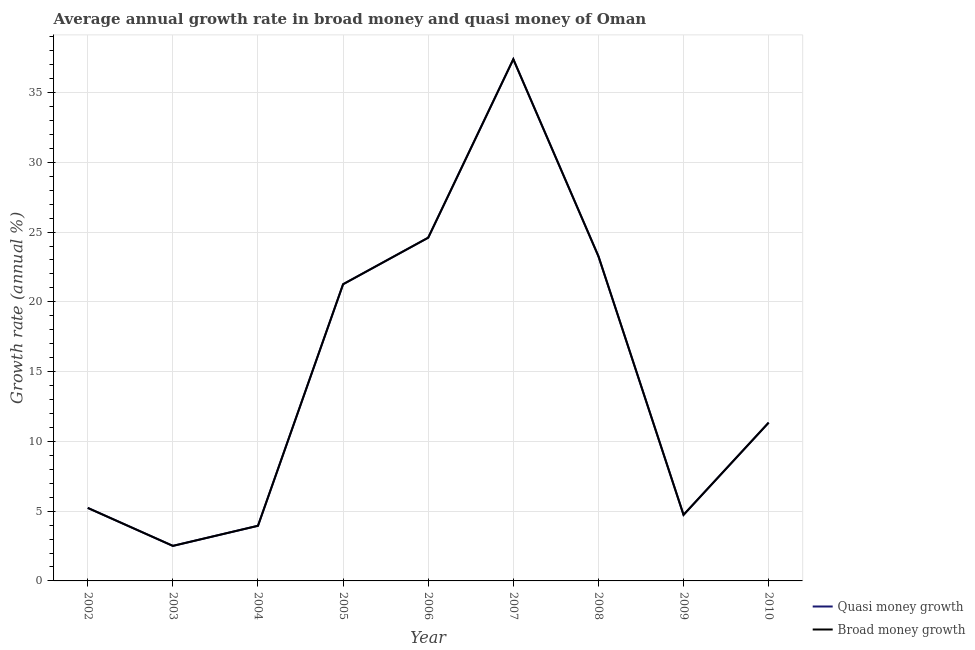Does the line corresponding to annual growth rate in broad money intersect with the line corresponding to annual growth rate in quasi money?
Offer a terse response. Yes. Is the number of lines equal to the number of legend labels?
Provide a succinct answer. Yes. What is the annual growth rate in quasi money in 2002?
Offer a very short reply. 5.23. Across all years, what is the maximum annual growth rate in quasi money?
Provide a succinct answer. 37.39. Across all years, what is the minimum annual growth rate in quasi money?
Provide a short and direct response. 2.51. In which year was the annual growth rate in quasi money minimum?
Offer a very short reply. 2003. What is the total annual growth rate in quasi money in the graph?
Keep it short and to the point. 134.28. What is the difference between the annual growth rate in broad money in 2005 and that in 2006?
Your response must be concise. -3.34. What is the difference between the annual growth rate in broad money in 2006 and the annual growth rate in quasi money in 2005?
Provide a succinct answer. 3.34. What is the average annual growth rate in broad money per year?
Offer a very short reply. 14.92. What is the ratio of the annual growth rate in quasi money in 2002 to that in 2008?
Give a very brief answer. 0.22. Is the annual growth rate in quasi money in 2002 less than that in 2003?
Give a very brief answer. No. What is the difference between the highest and the second highest annual growth rate in quasi money?
Provide a short and direct response. 12.79. What is the difference between the highest and the lowest annual growth rate in broad money?
Ensure brevity in your answer.  34.87. In how many years, is the annual growth rate in broad money greater than the average annual growth rate in broad money taken over all years?
Your answer should be very brief. 4. How many lines are there?
Keep it short and to the point. 2. Are the values on the major ticks of Y-axis written in scientific E-notation?
Your answer should be compact. No. Does the graph contain any zero values?
Ensure brevity in your answer.  No. Does the graph contain grids?
Keep it short and to the point. Yes. Where does the legend appear in the graph?
Ensure brevity in your answer.  Bottom right. What is the title of the graph?
Offer a terse response. Average annual growth rate in broad money and quasi money of Oman. Does "State government" appear as one of the legend labels in the graph?
Your answer should be very brief. No. What is the label or title of the X-axis?
Keep it short and to the point. Year. What is the label or title of the Y-axis?
Your answer should be very brief. Growth rate (annual %). What is the Growth rate (annual %) in Quasi money growth in 2002?
Your answer should be compact. 5.23. What is the Growth rate (annual %) in Broad money growth in 2002?
Offer a very short reply. 5.23. What is the Growth rate (annual %) in Quasi money growth in 2003?
Make the answer very short. 2.51. What is the Growth rate (annual %) of Broad money growth in 2003?
Your answer should be very brief. 2.51. What is the Growth rate (annual %) in Quasi money growth in 2004?
Offer a terse response. 3.95. What is the Growth rate (annual %) of Broad money growth in 2004?
Provide a short and direct response. 3.95. What is the Growth rate (annual %) of Quasi money growth in 2005?
Provide a succinct answer. 21.26. What is the Growth rate (annual %) of Broad money growth in 2005?
Keep it short and to the point. 21.26. What is the Growth rate (annual %) in Quasi money growth in 2006?
Give a very brief answer. 24.6. What is the Growth rate (annual %) in Broad money growth in 2006?
Offer a terse response. 24.6. What is the Growth rate (annual %) of Quasi money growth in 2007?
Your answer should be compact. 37.39. What is the Growth rate (annual %) of Broad money growth in 2007?
Offer a very short reply. 37.39. What is the Growth rate (annual %) of Quasi money growth in 2008?
Give a very brief answer. 23.27. What is the Growth rate (annual %) of Broad money growth in 2008?
Give a very brief answer. 23.27. What is the Growth rate (annual %) in Quasi money growth in 2009?
Your response must be concise. 4.73. What is the Growth rate (annual %) of Broad money growth in 2009?
Provide a succinct answer. 4.73. What is the Growth rate (annual %) in Quasi money growth in 2010?
Keep it short and to the point. 11.34. What is the Growth rate (annual %) of Broad money growth in 2010?
Give a very brief answer. 11.34. Across all years, what is the maximum Growth rate (annual %) of Quasi money growth?
Your answer should be very brief. 37.39. Across all years, what is the maximum Growth rate (annual %) of Broad money growth?
Offer a terse response. 37.39. Across all years, what is the minimum Growth rate (annual %) in Quasi money growth?
Your response must be concise. 2.51. Across all years, what is the minimum Growth rate (annual %) in Broad money growth?
Offer a very short reply. 2.51. What is the total Growth rate (annual %) of Quasi money growth in the graph?
Provide a short and direct response. 134.28. What is the total Growth rate (annual %) of Broad money growth in the graph?
Ensure brevity in your answer.  134.28. What is the difference between the Growth rate (annual %) in Quasi money growth in 2002 and that in 2003?
Make the answer very short. 2.72. What is the difference between the Growth rate (annual %) of Broad money growth in 2002 and that in 2003?
Provide a short and direct response. 2.72. What is the difference between the Growth rate (annual %) of Quasi money growth in 2002 and that in 2004?
Ensure brevity in your answer.  1.28. What is the difference between the Growth rate (annual %) in Broad money growth in 2002 and that in 2004?
Your response must be concise. 1.28. What is the difference between the Growth rate (annual %) of Quasi money growth in 2002 and that in 2005?
Offer a very short reply. -16.03. What is the difference between the Growth rate (annual %) of Broad money growth in 2002 and that in 2005?
Make the answer very short. -16.03. What is the difference between the Growth rate (annual %) of Quasi money growth in 2002 and that in 2006?
Provide a short and direct response. -19.36. What is the difference between the Growth rate (annual %) in Broad money growth in 2002 and that in 2006?
Give a very brief answer. -19.36. What is the difference between the Growth rate (annual %) of Quasi money growth in 2002 and that in 2007?
Ensure brevity in your answer.  -32.15. What is the difference between the Growth rate (annual %) in Broad money growth in 2002 and that in 2007?
Make the answer very short. -32.15. What is the difference between the Growth rate (annual %) in Quasi money growth in 2002 and that in 2008?
Keep it short and to the point. -18.03. What is the difference between the Growth rate (annual %) in Broad money growth in 2002 and that in 2008?
Provide a short and direct response. -18.03. What is the difference between the Growth rate (annual %) of Quasi money growth in 2002 and that in 2009?
Keep it short and to the point. 0.5. What is the difference between the Growth rate (annual %) of Broad money growth in 2002 and that in 2009?
Your answer should be compact. 0.5. What is the difference between the Growth rate (annual %) of Quasi money growth in 2002 and that in 2010?
Offer a very short reply. -6.11. What is the difference between the Growth rate (annual %) in Broad money growth in 2002 and that in 2010?
Your answer should be compact. -6.11. What is the difference between the Growth rate (annual %) in Quasi money growth in 2003 and that in 2004?
Make the answer very short. -1.44. What is the difference between the Growth rate (annual %) in Broad money growth in 2003 and that in 2004?
Ensure brevity in your answer.  -1.44. What is the difference between the Growth rate (annual %) of Quasi money growth in 2003 and that in 2005?
Ensure brevity in your answer.  -18.75. What is the difference between the Growth rate (annual %) in Broad money growth in 2003 and that in 2005?
Provide a short and direct response. -18.75. What is the difference between the Growth rate (annual %) of Quasi money growth in 2003 and that in 2006?
Offer a very short reply. -22.08. What is the difference between the Growth rate (annual %) in Broad money growth in 2003 and that in 2006?
Offer a very short reply. -22.08. What is the difference between the Growth rate (annual %) of Quasi money growth in 2003 and that in 2007?
Your answer should be compact. -34.87. What is the difference between the Growth rate (annual %) of Broad money growth in 2003 and that in 2007?
Ensure brevity in your answer.  -34.87. What is the difference between the Growth rate (annual %) in Quasi money growth in 2003 and that in 2008?
Give a very brief answer. -20.76. What is the difference between the Growth rate (annual %) in Broad money growth in 2003 and that in 2008?
Offer a terse response. -20.76. What is the difference between the Growth rate (annual %) in Quasi money growth in 2003 and that in 2009?
Offer a terse response. -2.22. What is the difference between the Growth rate (annual %) in Broad money growth in 2003 and that in 2009?
Give a very brief answer. -2.22. What is the difference between the Growth rate (annual %) in Quasi money growth in 2003 and that in 2010?
Offer a terse response. -8.83. What is the difference between the Growth rate (annual %) in Broad money growth in 2003 and that in 2010?
Ensure brevity in your answer.  -8.83. What is the difference between the Growth rate (annual %) of Quasi money growth in 2004 and that in 2005?
Give a very brief answer. -17.31. What is the difference between the Growth rate (annual %) of Broad money growth in 2004 and that in 2005?
Give a very brief answer. -17.31. What is the difference between the Growth rate (annual %) in Quasi money growth in 2004 and that in 2006?
Your answer should be compact. -20.64. What is the difference between the Growth rate (annual %) of Broad money growth in 2004 and that in 2006?
Your answer should be compact. -20.64. What is the difference between the Growth rate (annual %) in Quasi money growth in 2004 and that in 2007?
Provide a succinct answer. -33.43. What is the difference between the Growth rate (annual %) in Broad money growth in 2004 and that in 2007?
Offer a terse response. -33.43. What is the difference between the Growth rate (annual %) in Quasi money growth in 2004 and that in 2008?
Give a very brief answer. -19.31. What is the difference between the Growth rate (annual %) of Broad money growth in 2004 and that in 2008?
Your answer should be compact. -19.31. What is the difference between the Growth rate (annual %) in Quasi money growth in 2004 and that in 2009?
Ensure brevity in your answer.  -0.78. What is the difference between the Growth rate (annual %) of Broad money growth in 2004 and that in 2009?
Offer a terse response. -0.78. What is the difference between the Growth rate (annual %) in Quasi money growth in 2004 and that in 2010?
Your response must be concise. -7.39. What is the difference between the Growth rate (annual %) in Broad money growth in 2004 and that in 2010?
Offer a terse response. -7.39. What is the difference between the Growth rate (annual %) of Quasi money growth in 2005 and that in 2006?
Ensure brevity in your answer.  -3.34. What is the difference between the Growth rate (annual %) of Broad money growth in 2005 and that in 2006?
Your response must be concise. -3.34. What is the difference between the Growth rate (annual %) of Quasi money growth in 2005 and that in 2007?
Your response must be concise. -16.13. What is the difference between the Growth rate (annual %) in Broad money growth in 2005 and that in 2007?
Your answer should be very brief. -16.13. What is the difference between the Growth rate (annual %) of Quasi money growth in 2005 and that in 2008?
Give a very brief answer. -2.01. What is the difference between the Growth rate (annual %) of Broad money growth in 2005 and that in 2008?
Ensure brevity in your answer.  -2.01. What is the difference between the Growth rate (annual %) in Quasi money growth in 2005 and that in 2009?
Ensure brevity in your answer.  16.53. What is the difference between the Growth rate (annual %) in Broad money growth in 2005 and that in 2009?
Give a very brief answer. 16.53. What is the difference between the Growth rate (annual %) in Quasi money growth in 2005 and that in 2010?
Your answer should be compact. 9.92. What is the difference between the Growth rate (annual %) in Broad money growth in 2005 and that in 2010?
Give a very brief answer. 9.92. What is the difference between the Growth rate (annual %) in Quasi money growth in 2006 and that in 2007?
Offer a very short reply. -12.79. What is the difference between the Growth rate (annual %) in Broad money growth in 2006 and that in 2007?
Ensure brevity in your answer.  -12.79. What is the difference between the Growth rate (annual %) in Quasi money growth in 2006 and that in 2008?
Your response must be concise. 1.33. What is the difference between the Growth rate (annual %) in Broad money growth in 2006 and that in 2008?
Ensure brevity in your answer.  1.33. What is the difference between the Growth rate (annual %) in Quasi money growth in 2006 and that in 2009?
Offer a very short reply. 19.86. What is the difference between the Growth rate (annual %) of Broad money growth in 2006 and that in 2009?
Give a very brief answer. 19.86. What is the difference between the Growth rate (annual %) in Quasi money growth in 2006 and that in 2010?
Give a very brief answer. 13.25. What is the difference between the Growth rate (annual %) in Broad money growth in 2006 and that in 2010?
Make the answer very short. 13.25. What is the difference between the Growth rate (annual %) of Quasi money growth in 2007 and that in 2008?
Your response must be concise. 14.12. What is the difference between the Growth rate (annual %) in Broad money growth in 2007 and that in 2008?
Your answer should be compact. 14.12. What is the difference between the Growth rate (annual %) in Quasi money growth in 2007 and that in 2009?
Make the answer very short. 32.65. What is the difference between the Growth rate (annual %) in Broad money growth in 2007 and that in 2009?
Your answer should be compact. 32.65. What is the difference between the Growth rate (annual %) of Quasi money growth in 2007 and that in 2010?
Provide a succinct answer. 26.04. What is the difference between the Growth rate (annual %) of Broad money growth in 2007 and that in 2010?
Offer a terse response. 26.04. What is the difference between the Growth rate (annual %) of Quasi money growth in 2008 and that in 2009?
Your answer should be compact. 18.53. What is the difference between the Growth rate (annual %) in Broad money growth in 2008 and that in 2009?
Ensure brevity in your answer.  18.53. What is the difference between the Growth rate (annual %) in Quasi money growth in 2008 and that in 2010?
Offer a very short reply. 11.92. What is the difference between the Growth rate (annual %) in Broad money growth in 2008 and that in 2010?
Give a very brief answer. 11.92. What is the difference between the Growth rate (annual %) in Quasi money growth in 2009 and that in 2010?
Make the answer very short. -6.61. What is the difference between the Growth rate (annual %) of Broad money growth in 2009 and that in 2010?
Your answer should be compact. -6.61. What is the difference between the Growth rate (annual %) of Quasi money growth in 2002 and the Growth rate (annual %) of Broad money growth in 2003?
Make the answer very short. 2.72. What is the difference between the Growth rate (annual %) of Quasi money growth in 2002 and the Growth rate (annual %) of Broad money growth in 2004?
Make the answer very short. 1.28. What is the difference between the Growth rate (annual %) in Quasi money growth in 2002 and the Growth rate (annual %) in Broad money growth in 2005?
Keep it short and to the point. -16.03. What is the difference between the Growth rate (annual %) in Quasi money growth in 2002 and the Growth rate (annual %) in Broad money growth in 2006?
Your answer should be very brief. -19.36. What is the difference between the Growth rate (annual %) in Quasi money growth in 2002 and the Growth rate (annual %) in Broad money growth in 2007?
Offer a very short reply. -32.15. What is the difference between the Growth rate (annual %) in Quasi money growth in 2002 and the Growth rate (annual %) in Broad money growth in 2008?
Provide a succinct answer. -18.03. What is the difference between the Growth rate (annual %) in Quasi money growth in 2002 and the Growth rate (annual %) in Broad money growth in 2009?
Make the answer very short. 0.5. What is the difference between the Growth rate (annual %) of Quasi money growth in 2002 and the Growth rate (annual %) of Broad money growth in 2010?
Provide a short and direct response. -6.11. What is the difference between the Growth rate (annual %) of Quasi money growth in 2003 and the Growth rate (annual %) of Broad money growth in 2004?
Your answer should be compact. -1.44. What is the difference between the Growth rate (annual %) of Quasi money growth in 2003 and the Growth rate (annual %) of Broad money growth in 2005?
Offer a very short reply. -18.75. What is the difference between the Growth rate (annual %) in Quasi money growth in 2003 and the Growth rate (annual %) in Broad money growth in 2006?
Make the answer very short. -22.08. What is the difference between the Growth rate (annual %) of Quasi money growth in 2003 and the Growth rate (annual %) of Broad money growth in 2007?
Your answer should be very brief. -34.87. What is the difference between the Growth rate (annual %) of Quasi money growth in 2003 and the Growth rate (annual %) of Broad money growth in 2008?
Give a very brief answer. -20.76. What is the difference between the Growth rate (annual %) of Quasi money growth in 2003 and the Growth rate (annual %) of Broad money growth in 2009?
Offer a very short reply. -2.22. What is the difference between the Growth rate (annual %) of Quasi money growth in 2003 and the Growth rate (annual %) of Broad money growth in 2010?
Offer a very short reply. -8.83. What is the difference between the Growth rate (annual %) of Quasi money growth in 2004 and the Growth rate (annual %) of Broad money growth in 2005?
Your response must be concise. -17.31. What is the difference between the Growth rate (annual %) in Quasi money growth in 2004 and the Growth rate (annual %) in Broad money growth in 2006?
Give a very brief answer. -20.64. What is the difference between the Growth rate (annual %) in Quasi money growth in 2004 and the Growth rate (annual %) in Broad money growth in 2007?
Give a very brief answer. -33.43. What is the difference between the Growth rate (annual %) in Quasi money growth in 2004 and the Growth rate (annual %) in Broad money growth in 2008?
Offer a terse response. -19.31. What is the difference between the Growth rate (annual %) of Quasi money growth in 2004 and the Growth rate (annual %) of Broad money growth in 2009?
Give a very brief answer. -0.78. What is the difference between the Growth rate (annual %) of Quasi money growth in 2004 and the Growth rate (annual %) of Broad money growth in 2010?
Give a very brief answer. -7.39. What is the difference between the Growth rate (annual %) of Quasi money growth in 2005 and the Growth rate (annual %) of Broad money growth in 2006?
Make the answer very short. -3.34. What is the difference between the Growth rate (annual %) in Quasi money growth in 2005 and the Growth rate (annual %) in Broad money growth in 2007?
Provide a short and direct response. -16.13. What is the difference between the Growth rate (annual %) in Quasi money growth in 2005 and the Growth rate (annual %) in Broad money growth in 2008?
Offer a terse response. -2.01. What is the difference between the Growth rate (annual %) of Quasi money growth in 2005 and the Growth rate (annual %) of Broad money growth in 2009?
Give a very brief answer. 16.53. What is the difference between the Growth rate (annual %) in Quasi money growth in 2005 and the Growth rate (annual %) in Broad money growth in 2010?
Provide a succinct answer. 9.92. What is the difference between the Growth rate (annual %) of Quasi money growth in 2006 and the Growth rate (annual %) of Broad money growth in 2007?
Your response must be concise. -12.79. What is the difference between the Growth rate (annual %) in Quasi money growth in 2006 and the Growth rate (annual %) in Broad money growth in 2008?
Your answer should be compact. 1.33. What is the difference between the Growth rate (annual %) in Quasi money growth in 2006 and the Growth rate (annual %) in Broad money growth in 2009?
Offer a terse response. 19.86. What is the difference between the Growth rate (annual %) of Quasi money growth in 2006 and the Growth rate (annual %) of Broad money growth in 2010?
Offer a terse response. 13.25. What is the difference between the Growth rate (annual %) of Quasi money growth in 2007 and the Growth rate (annual %) of Broad money growth in 2008?
Ensure brevity in your answer.  14.12. What is the difference between the Growth rate (annual %) in Quasi money growth in 2007 and the Growth rate (annual %) in Broad money growth in 2009?
Provide a short and direct response. 32.65. What is the difference between the Growth rate (annual %) in Quasi money growth in 2007 and the Growth rate (annual %) in Broad money growth in 2010?
Your response must be concise. 26.04. What is the difference between the Growth rate (annual %) of Quasi money growth in 2008 and the Growth rate (annual %) of Broad money growth in 2009?
Your answer should be very brief. 18.53. What is the difference between the Growth rate (annual %) of Quasi money growth in 2008 and the Growth rate (annual %) of Broad money growth in 2010?
Your response must be concise. 11.92. What is the difference between the Growth rate (annual %) of Quasi money growth in 2009 and the Growth rate (annual %) of Broad money growth in 2010?
Provide a short and direct response. -6.61. What is the average Growth rate (annual %) of Quasi money growth per year?
Ensure brevity in your answer.  14.92. What is the average Growth rate (annual %) in Broad money growth per year?
Provide a short and direct response. 14.92. In the year 2002, what is the difference between the Growth rate (annual %) of Quasi money growth and Growth rate (annual %) of Broad money growth?
Make the answer very short. 0. In the year 2003, what is the difference between the Growth rate (annual %) in Quasi money growth and Growth rate (annual %) in Broad money growth?
Provide a succinct answer. 0. In the year 2004, what is the difference between the Growth rate (annual %) of Quasi money growth and Growth rate (annual %) of Broad money growth?
Make the answer very short. 0. In the year 2006, what is the difference between the Growth rate (annual %) of Quasi money growth and Growth rate (annual %) of Broad money growth?
Ensure brevity in your answer.  0. In the year 2007, what is the difference between the Growth rate (annual %) in Quasi money growth and Growth rate (annual %) in Broad money growth?
Give a very brief answer. 0. In the year 2008, what is the difference between the Growth rate (annual %) of Quasi money growth and Growth rate (annual %) of Broad money growth?
Your answer should be very brief. 0. In the year 2010, what is the difference between the Growth rate (annual %) of Quasi money growth and Growth rate (annual %) of Broad money growth?
Your answer should be compact. 0. What is the ratio of the Growth rate (annual %) in Quasi money growth in 2002 to that in 2003?
Your answer should be very brief. 2.08. What is the ratio of the Growth rate (annual %) of Broad money growth in 2002 to that in 2003?
Make the answer very short. 2.08. What is the ratio of the Growth rate (annual %) in Quasi money growth in 2002 to that in 2004?
Provide a short and direct response. 1.32. What is the ratio of the Growth rate (annual %) in Broad money growth in 2002 to that in 2004?
Provide a short and direct response. 1.32. What is the ratio of the Growth rate (annual %) in Quasi money growth in 2002 to that in 2005?
Ensure brevity in your answer.  0.25. What is the ratio of the Growth rate (annual %) in Broad money growth in 2002 to that in 2005?
Offer a terse response. 0.25. What is the ratio of the Growth rate (annual %) of Quasi money growth in 2002 to that in 2006?
Provide a succinct answer. 0.21. What is the ratio of the Growth rate (annual %) of Broad money growth in 2002 to that in 2006?
Offer a terse response. 0.21. What is the ratio of the Growth rate (annual %) of Quasi money growth in 2002 to that in 2007?
Keep it short and to the point. 0.14. What is the ratio of the Growth rate (annual %) in Broad money growth in 2002 to that in 2007?
Give a very brief answer. 0.14. What is the ratio of the Growth rate (annual %) in Quasi money growth in 2002 to that in 2008?
Your response must be concise. 0.22. What is the ratio of the Growth rate (annual %) of Broad money growth in 2002 to that in 2008?
Your answer should be very brief. 0.22. What is the ratio of the Growth rate (annual %) in Quasi money growth in 2002 to that in 2009?
Your response must be concise. 1.1. What is the ratio of the Growth rate (annual %) of Broad money growth in 2002 to that in 2009?
Offer a terse response. 1.1. What is the ratio of the Growth rate (annual %) in Quasi money growth in 2002 to that in 2010?
Ensure brevity in your answer.  0.46. What is the ratio of the Growth rate (annual %) of Broad money growth in 2002 to that in 2010?
Ensure brevity in your answer.  0.46. What is the ratio of the Growth rate (annual %) of Quasi money growth in 2003 to that in 2004?
Your answer should be compact. 0.64. What is the ratio of the Growth rate (annual %) of Broad money growth in 2003 to that in 2004?
Your answer should be compact. 0.64. What is the ratio of the Growth rate (annual %) in Quasi money growth in 2003 to that in 2005?
Offer a very short reply. 0.12. What is the ratio of the Growth rate (annual %) of Broad money growth in 2003 to that in 2005?
Keep it short and to the point. 0.12. What is the ratio of the Growth rate (annual %) in Quasi money growth in 2003 to that in 2006?
Your answer should be very brief. 0.1. What is the ratio of the Growth rate (annual %) of Broad money growth in 2003 to that in 2006?
Provide a short and direct response. 0.1. What is the ratio of the Growth rate (annual %) of Quasi money growth in 2003 to that in 2007?
Give a very brief answer. 0.07. What is the ratio of the Growth rate (annual %) of Broad money growth in 2003 to that in 2007?
Provide a short and direct response. 0.07. What is the ratio of the Growth rate (annual %) of Quasi money growth in 2003 to that in 2008?
Your answer should be compact. 0.11. What is the ratio of the Growth rate (annual %) in Broad money growth in 2003 to that in 2008?
Provide a short and direct response. 0.11. What is the ratio of the Growth rate (annual %) in Quasi money growth in 2003 to that in 2009?
Ensure brevity in your answer.  0.53. What is the ratio of the Growth rate (annual %) in Broad money growth in 2003 to that in 2009?
Make the answer very short. 0.53. What is the ratio of the Growth rate (annual %) of Quasi money growth in 2003 to that in 2010?
Offer a very short reply. 0.22. What is the ratio of the Growth rate (annual %) of Broad money growth in 2003 to that in 2010?
Keep it short and to the point. 0.22. What is the ratio of the Growth rate (annual %) of Quasi money growth in 2004 to that in 2005?
Give a very brief answer. 0.19. What is the ratio of the Growth rate (annual %) in Broad money growth in 2004 to that in 2005?
Provide a succinct answer. 0.19. What is the ratio of the Growth rate (annual %) of Quasi money growth in 2004 to that in 2006?
Offer a very short reply. 0.16. What is the ratio of the Growth rate (annual %) of Broad money growth in 2004 to that in 2006?
Offer a terse response. 0.16. What is the ratio of the Growth rate (annual %) of Quasi money growth in 2004 to that in 2007?
Your answer should be very brief. 0.11. What is the ratio of the Growth rate (annual %) of Broad money growth in 2004 to that in 2007?
Your response must be concise. 0.11. What is the ratio of the Growth rate (annual %) in Quasi money growth in 2004 to that in 2008?
Offer a very short reply. 0.17. What is the ratio of the Growth rate (annual %) in Broad money growth in 2004 to that in 2008?
Provide a succinct answer. 0.17. What is the ratio of the Growth rate (annual %) of Quasi money growth in 2004 to that in 2009?
Offer a very short reply. 0.83. What is the ratio of the Growth rate (annual %) of Broad money growth in 2004 to that in 2009?
Offer a terse response. 0.83. What is the ratio of the Growth rate (annual %) of Quasi money growth in 2004 to that in 2010?
Keep it short and to the point. 0.35. What is the ratio of the Growth rate (annual %) in Broad money growth in 2004 to that in 2010?
Make the answer very short. 0.35. What is the ratio of the Growth rate (annual %) in Quasi money growth in 2005 to that in 2006?
Your response must be concise. 0.86. What is the ratio of the Growth rate (annual %) of Broad money growth in 2005 to that in 2006?
Provide a succinct answer. 0.86. What is the ratio of the Growth rate (annual %) of Quasi money growth in 2005 to that in 2007?
Offer a terse response. 0.57. What is the ratio of the Growth rate (annual %) in Broad money growth in 2005 to that in 2007?
Make the answer very short. 0.57. What is the ratio of the Growth rate (annual %) of Quasi money growth in 2005 to that in 2008?
Offer a terse response. 0.91. What is the ratio of the Growth rate (annual %) of Broad money growth in 2005 to that in 2008?
Your response must be concise. 0.91. What is the ratio of the Growth rate (annual %) in Quasi money growth in 2005 to that in 2009?
Make the answer very short. 4.49. What is the ratio of the Growth rate (annual %) in Broad money growth in 2005 to that in 2009?
Provide a short and direct response. 4.49. What is the ratio of the Growth rate (annual %) of Quasi money growth in 2005 to that in 2010?
Your answer should be compact. 1.87. What is the ratio of the Growth rate (annual %) of Broad money growth in 2005 to that in 2010?
Your response must be concise. 1.87. What is the ratio of the Growth rate (annual %) in Quasi money growth in 2006 to that in 2007?
Provide a short and direct response. 0.66. What is the ratio of the Growth rate (annual %) of Broad money growth in 2006 to that in 2007?
Provide a succinct answer. 0.66. What is the ratio of the Growth rate (annual %) in Quasi money growth in 2006 to that in 2008?
Ensure brevity in your answer.  1.06. What is the ratio of the Growth rate (annual %) in Broad money growth in 2006 to that in 2008?
Give a very brief answer. 1.06. What is the ratio of the Growth rate (annual %) of Quasi money growth in 2006 to that in 2009?
Give a very brief answer. 5.19. What is the ratio of the Growth rate (annual %) in Broad money growth in 2006 to that in 2009?
Provide a short and direct response. 5.19. What is the ratio of the Growth rate (annual %) of Quasi money growth in 2006 to that in 2010?
Ensure brevity in your answer.  2.17. What is the ratio of the Growth rate (annual %) in Broad money growth in 2006 to that in 2010?
Give a very brief answer. 2.17. What is the ratio of the Growth rate (annual %) in Quasi money growth in 2007 to that in 2008?
Offer a very short reply. 1.61. What is the ratio of the Growth rate (annual %) in Broad money growth in 2007 to that in 2008?
Offer a very short reply. 1.61. What is the ratio of the Growth rate (annual %) in Quasi money growth in 2007 to that in 2009?
Your answer should be very brief. 7.9. What is the ratio of the Growth rate (annual %) in Broad money growth in 2007 to that in 2009?
Your answer should be very brief. 7.9. What is the ratio of the Growth rate (annual %) in Quasi money growth in 2007 to that in 2010?
Make the answer very short. 3.3. What is the ratio of the Growth rate (annual %) of Broad money growth in 2007 to that in 2010?
Ensure brevity in your answer.  3.3. What is the ratio of the Growth rate (annual %) of Quasi money growth in 2008 to that in 2009?
Your answer should be compact. 4.91. What is the ratio of the Growth rate (annual %) of Broad money growth in 2008 to that in 2009?
Your response must be concise. 4.91. What is the ratio of the Growth rate (annual %) in Quasi money growth in 2008 to that in 2010?
Offer a very short reply. 2.05. What is the ratio of the Growth rate (annual %) of Broad money growth in 2008 to that in 2010?
Your response must be concise. 2.05. What is the ratio of the Growth rate (annual %) of Quasi money growth in 2009 to that in 2010?
Offer a terse response. 0.42. What is the ratio of the Growth rate (annual %) in Broad money growth in 2009 to that in 2010?
Your answer should be very brief. 0.42. What is the difference between the highest and the second highest Growth rate (annual %) of Quasi money growth?
Give a very brief answer. 12.79. What is the difference between the highest and the second highest Growth rate (annual %) in Broad money growth?
Keep it short and to the point. 12.79. What is the difference between the highest and the lowest Growth rate (annual %) of Quasi money growth?
Keep it short and to the point. 34.87. What is the difference between the highest and the lowest Growth rate (annual %) of Broad money growth?
Provide a short and direct response. 34.87. 